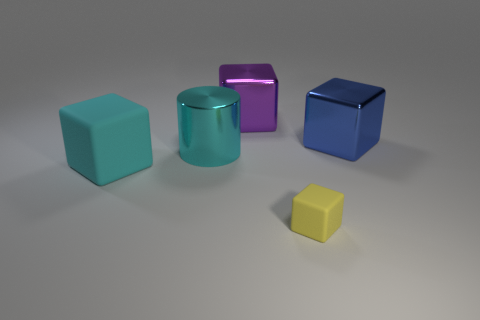Subtract 1 cubes. How many cubes are left? 3 Subtract all red cylinders. Subtract all yellow blocks. How many cylinders are left? 1 Add 2 small yellow cubes. How many objects exist? 7 Subtract all cylinders. How many objects are left? 4 Subtract all big metallic blocks. Subtract all large yellow matte spheres. How many objects are left? 3 Add 3 purple blocks. How many purple blocks are left? 4 Add 1 big blue metallic objects. How many big blue metallic objects exist? 2 Subtract 1 yellow blocks. How many objects are left? 4 